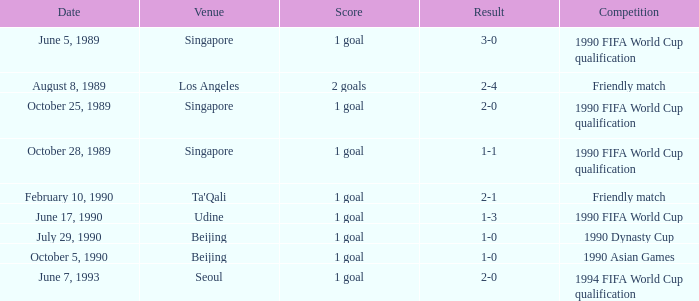What was the venue where the result was 2-1? Ta'Qali. 